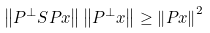Convert formula to latex. <formula><loc_0><loc_0><loc_500><loc_500>\left \| P ^ { \perp } S P x \right \| \left \| P ^ { \perp } x \right \| \geq \left \| P x \right \| ^ { 2 }</formula> 